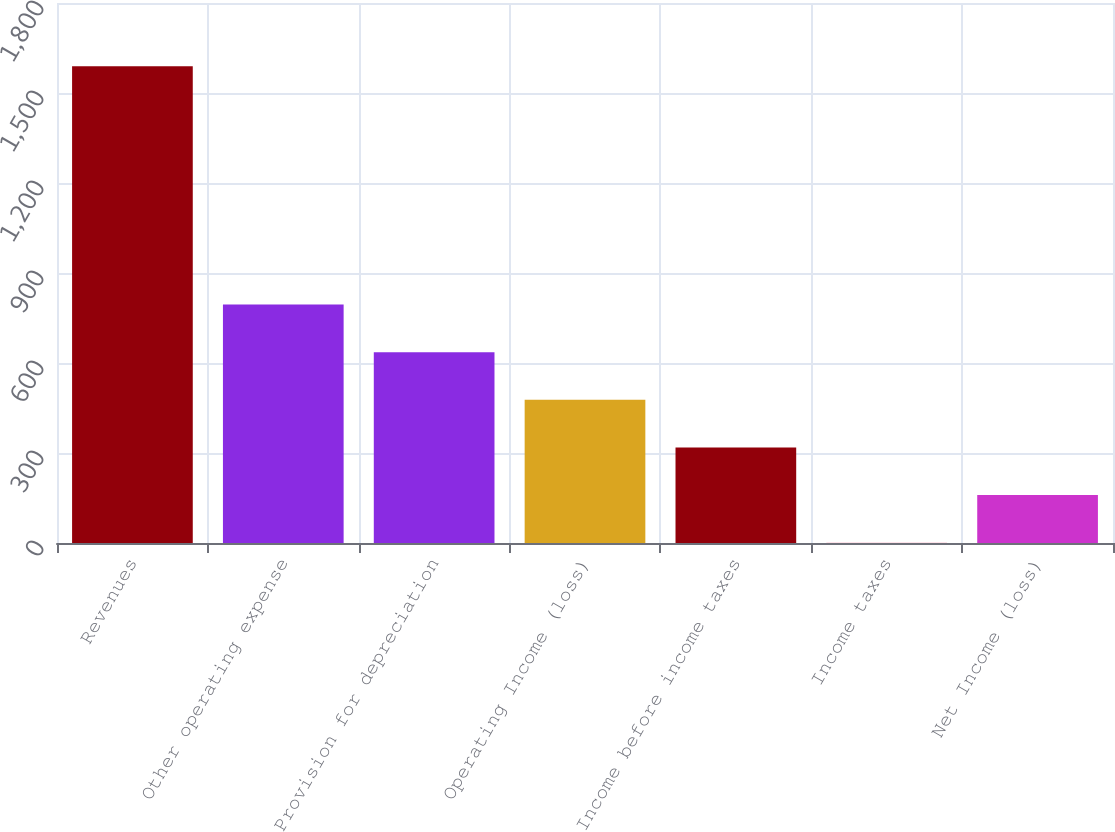Convert chart. <chart><loc_0><loc_0><loc_500><loc_500><bar_chart><fcel>Revenues<fcel>Other operating expense<fcel>Provision for depreciation<fcel>Operating Income (loss)<fcel>Income before income taxes<fcel>Income taxes<fcel>Net Income (loss)<nl><fcel>1589<fcel>795<fcel>636.2<fcel>477.4<fcel>318.6<fcel>1<fcel>159.8<nl></chart> 